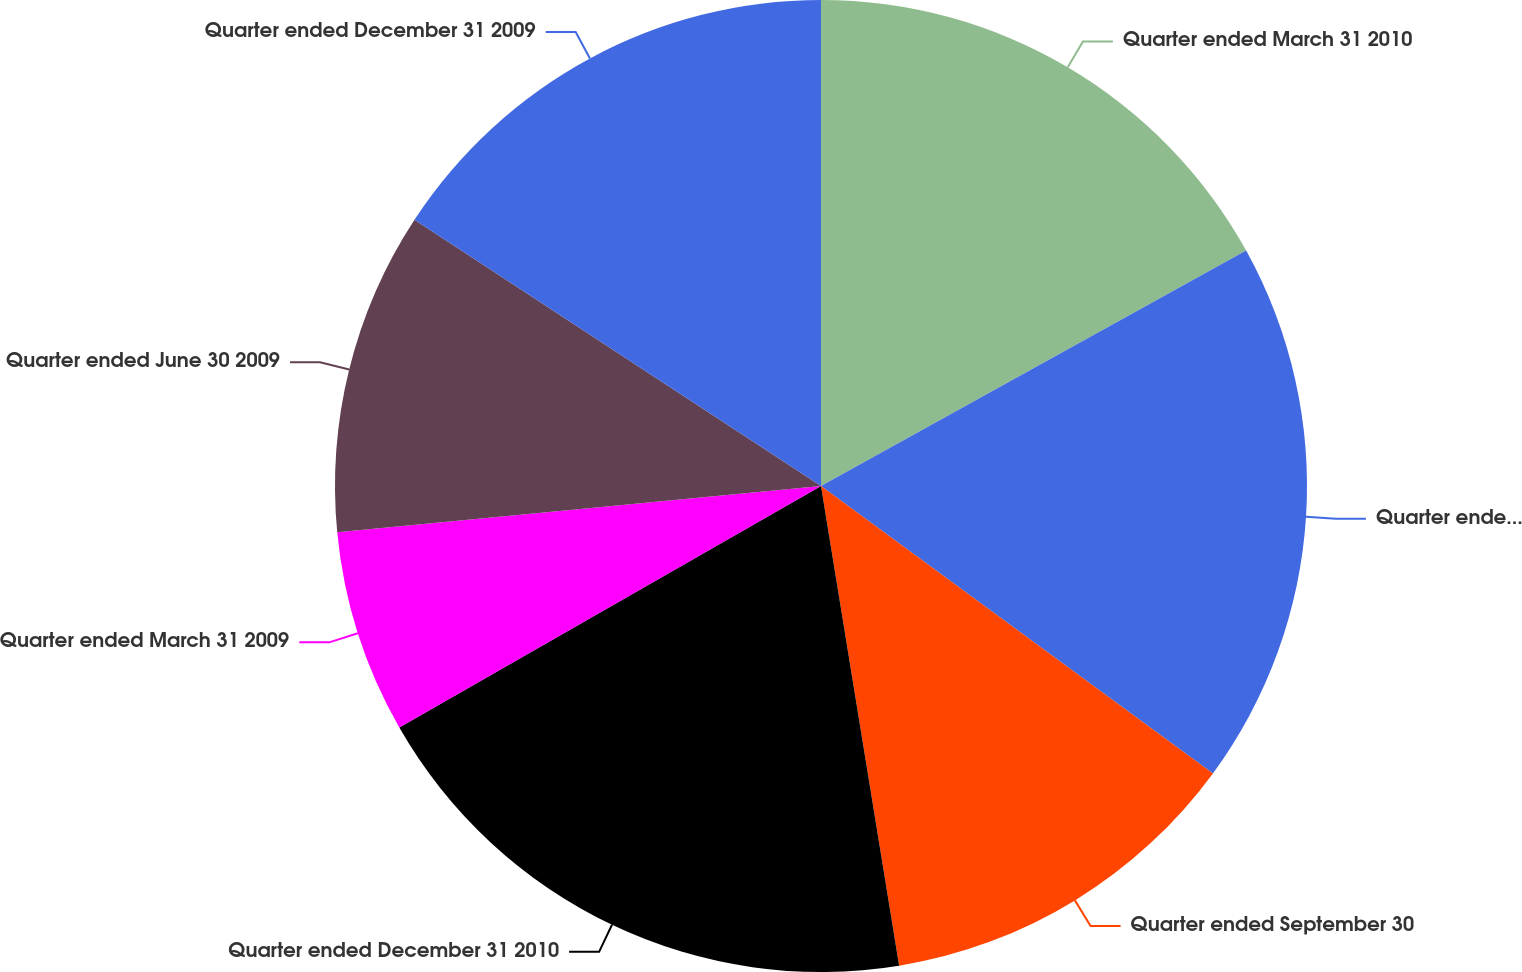Convert chart to OTSL. <chart><loc_0><loc_0><loc_500><loc_500><pie_chart><fcel>Quarter ended March 31 2010<fcel>Quarter ended June 30 2010<fcel>Quarter ended September 30<fcel>Quarter ended December 31 2010<fcel>Quarter ended March 31 2009<fcel>Quarter ended June 30 2009<fcel>Quarter ended December 31 2009<nl><fcel>16.95%<fcel>18.12%<fcel>12.36%<fcel>19.29%<fcel>6.76%<fcel>10.75%<fcel>15.77%<nl></chart> 